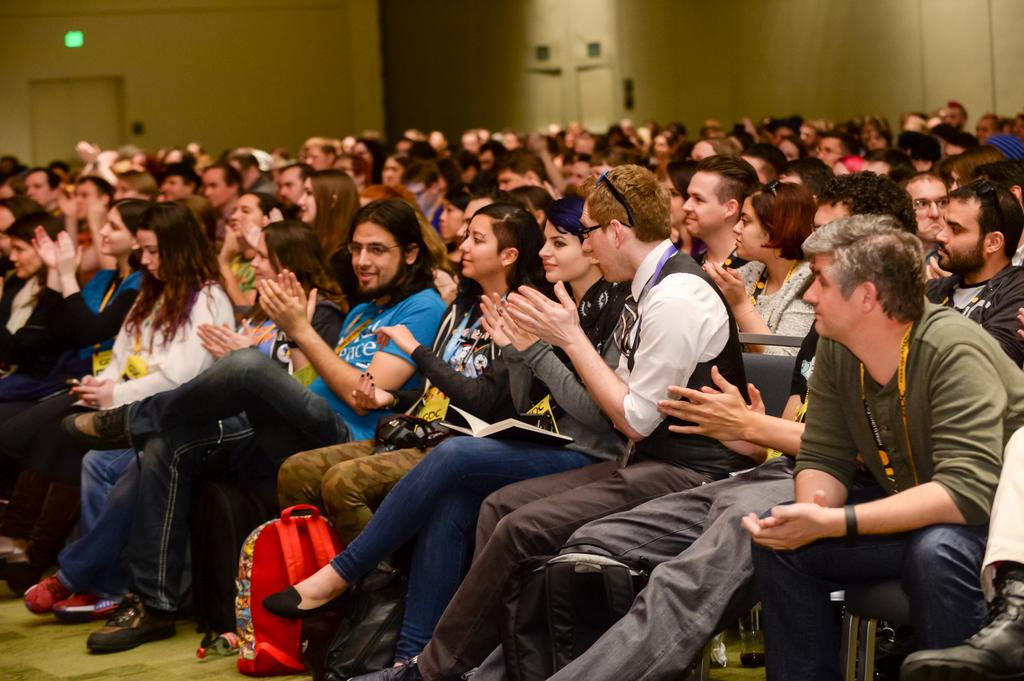What are the people in the image doing? The people in the image are sitting on chairs. What can be seen in the background of the image? There is a wall in the background of the image. How does the person in the image use their wing to connect with others? There is no person with a wing present in the image, so this question cannot be answered. 